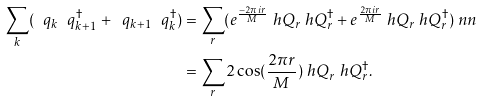<formula> <loc_0><loc_0><loc_500><loc_500>\sum _ { k } ( \ q _ { k } \ q _ { k + 1 } ^ { \dagger } + \ q _ { k + 1 } \ q _ { k } ^ { \dagger } ) & = \sum _ { r } ( e ^ { \frac { - 2 \pi i r } { M } } \ h Q _ { r } \ h Q _ { r } ^ { \dagger } + e ^ { \frac { 2 \pi i r } { M } } \ h Q _ { r } \ h Q _ { r } ^ { \dagger } ) \ n n \\ & = \sum _ { r } 2 \cos ( \frac { 2 \pi r } { M } ) \ h Q _ { r } \ h Q _ { r } ^ { \dagger } .</formula> 